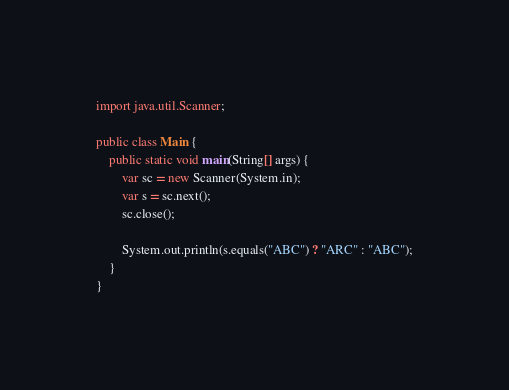<code> <loc_0><loc_0><loc_500><loc_500><_Java_>import java.util.Scanner;

public class Main {
	public static void main(String[] args) {
		var sc = new Scanner(System.in);
		var s = sc.next();
		sc.close();

		System.out.println(s.equals("ABC") ? "ARC" : "ABC");
	}
}</code> 